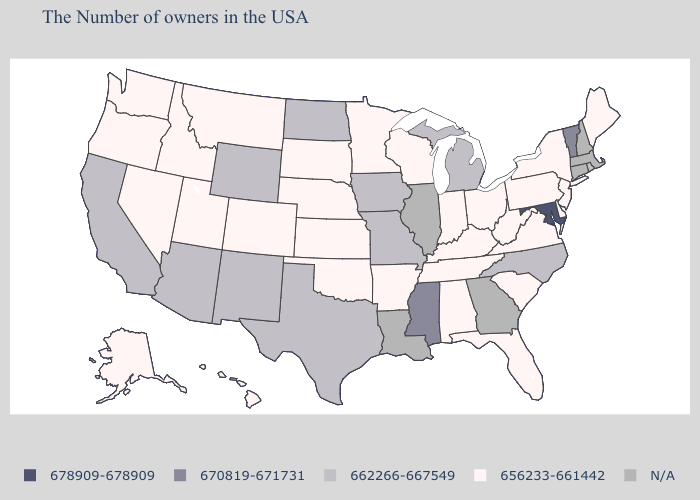Name the states that have a value in the range N/A?
Concise answer only. Massachusetts, New Hampshire, Connecticut, Georgia, Illinois, Louisiana. What is the lowest value in the South?
Concise answer only. 656233-661442. Does Rhode Island have the lowest value in the USA?
Write a very short answer. No. Which states have the highest value in the USA?
Short answer required. Maryland. What is the value of Wyoming?
Keep it brief. 662266-667549. What is the value of Rhode Island?
Short answer required. 662266-667549. Among the states that border Montana , which have the lowest value?
Write a very short answer. South Dakota, Idaho. What is the lowest value in the USA?
Concise answer only. 656233-661442. Name the states that have a value in the range 678909-678909?
Be succinct. Maryland. Which states have the lowest value in the Northeast?
Be succinct. Maine, New York, New Jersey, Pennsylvania. What is the highest value in states that border Nevada?
Concise answer only. 662266-667549. Name the states that have a value in the range 656233-661442?
Quick response, please. Maine, New York, New Jersey, Delaware, Pennsylvania, Virginia, South Carolina, West Virginia, Ohio, Florida, Kentucky, Indiana, Alabama, Tennessee, Wisconsin, Arkansas, Minnesota, Kansas, Nebraska, Oklahoma, South Dakota, Colorado, Utah, Montana, Idaho, Nevada, Washington, Oregon, Alaska, Hawaii. Name the states that have a value in the range N/A?
Keep it brief. Massachusetts, New Hampshire, Connecticut, Georgia, Illinois, Louisiana. Does the first symbol in the legend represent the smallest category?
Be succinct. No. How many symbols are there in the legend?
Give a very brief answer. 5. 